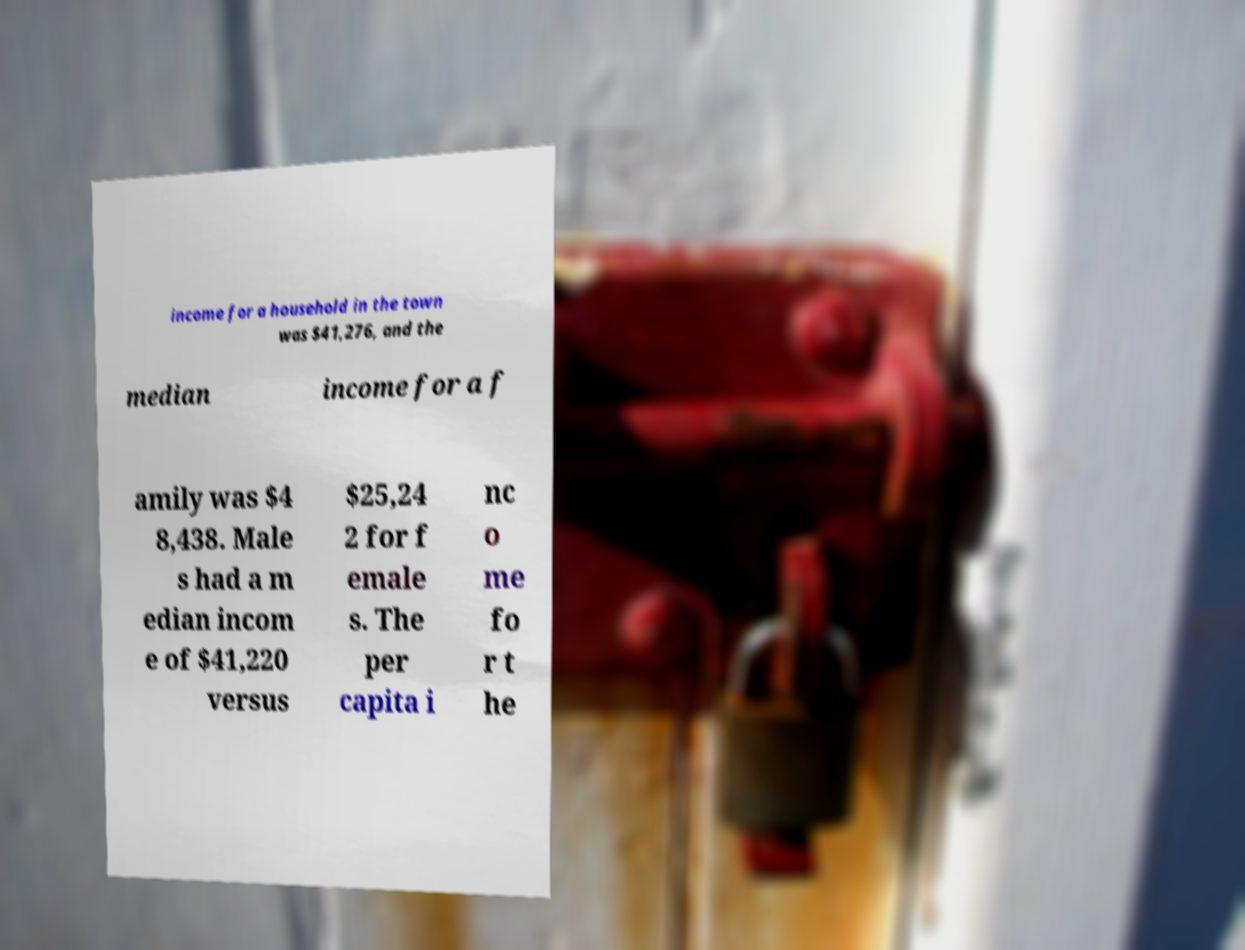Can you read and provide the text displayed in the image?This photo seems to have some interesting text. Can you extract and type it out for me? income for a household in the town was $41,276, and the median income for a f amily was $4 8,438. Male s had a m edian incom e of $41,220 versus $25,24 2 for f emale s. The per capita i nc o me fo r t he 